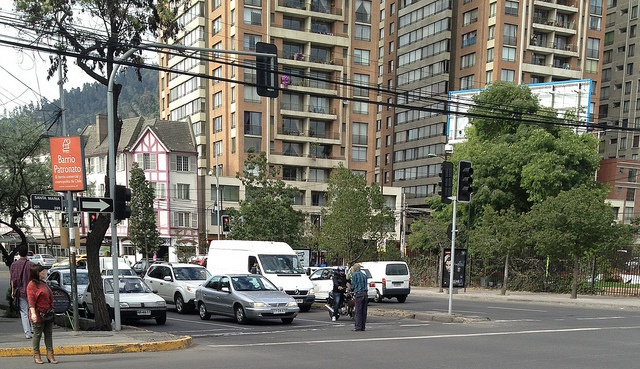Describe the objects in this image and their specific colors. I can see car in white, gray, black, and darkgray tones, car in white, black, gray, darkgray, and lightgray tones, car in white, black, gray, lightgray, and darkgray tones, car in white, darkgray, black, and gray tones, and people in white, black, maroon, brown, and gray tones in this image. 